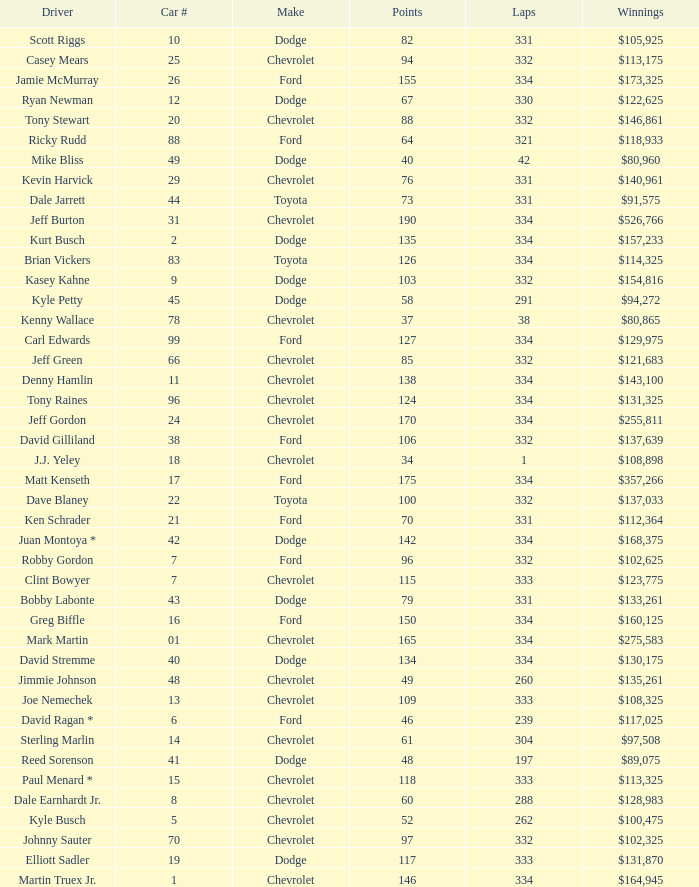How many total laps did the Chevrolet that won $97,508 make? 1.0. 